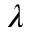<formula> <loc_0><loc_0><loc_500><loc_500>\lambda</formula> 